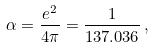Convert formula to latex. <formula><loc_0><loc_0><loc_500><loc_500>\alpha = \frac { e ^ { 2 } } { 4 \pi } = \frac { 1 } { 1 3 7 . 0 3 6 } \, ,</formula> 